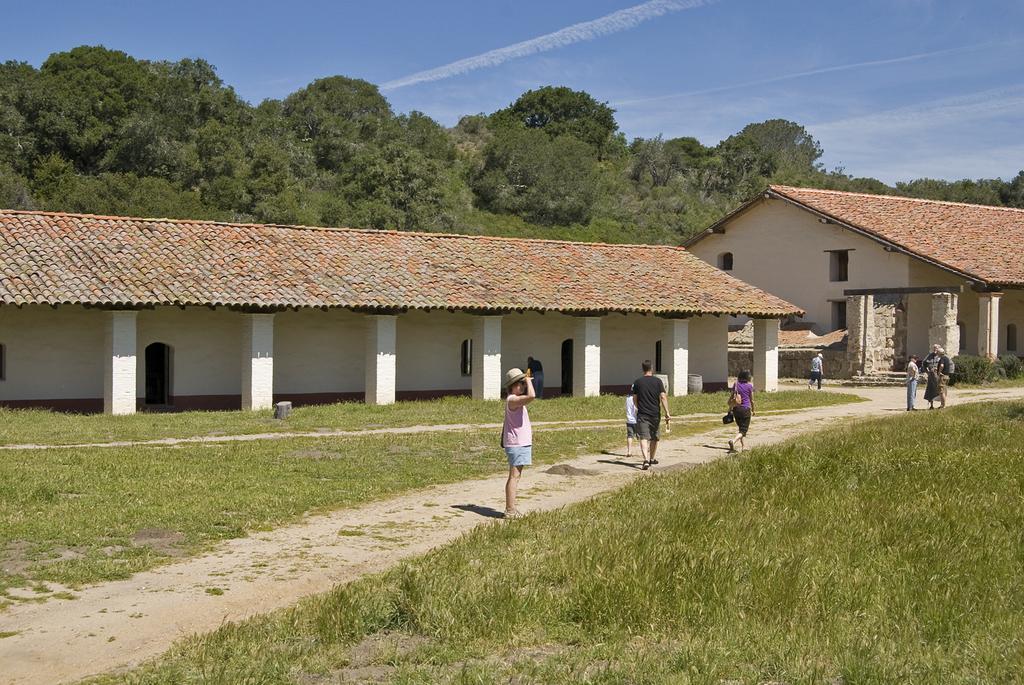Please provide a concise description of this image. In the center of the image there are people walking on the road. On both right and left side of the image there is grass on the surface. In the background of the image there are building, trees and sky. 